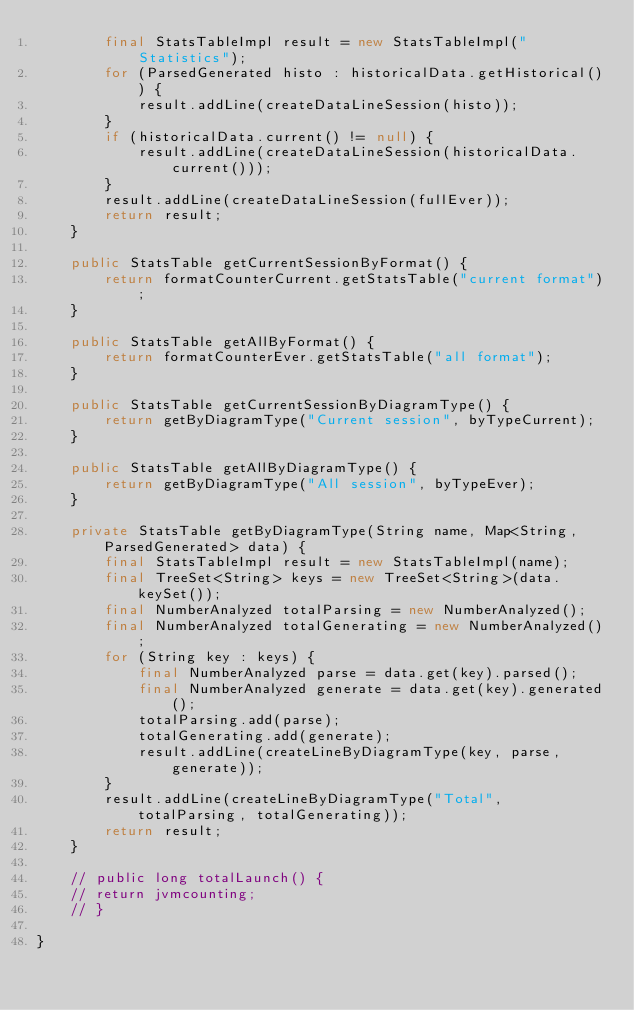<code> <loc_0><loc_0><loc_500><loc_500><_Java_>		final StatsTableImpl result = new StatsTableImpl("Statistics");
		for (ParsedGenerated histo : historicalData.getHistorical()) {
			result.addLine(createDataLineSession(histo));
		}
		if (historicalData.current() != null) {
			result.addLine(createDataLineSession(historicalData.current()));
		}
		result.addLine(createDataLineSession(fullEver));
		return result;
	}

	public StatsTable getCurrentSessionByFormat() {
		return formatCounterCurrent.getStatsTable("current format");
	}

	public StatsTable getAllByFormat() {
		return formatCounterEver.getStatsTable("all format");
	}

	public StatsTable getCurrentSessionByDiagramType() {
		return getByDiagramType("Current session", byTypeCurrent);
	}

	public StatsTable getAllByDiagramType() {
		return getByDiagramType("All session", byTypeEver);
	}

	private StatsTable getByDiagramType(String name, Map<String, ParsedGenerated> data) {
		final StatsTableImpl result = new StatsTableImpl(name);
		final TreeSet<String> keys = new TreeSet<String>(data.keySet());
		final NumberAnalyzed totalParsing = new NumberAnalyzed();
		final NumberAnalyzed totalGenerating = new NumberAnalyzed();
		for (String key : keys) {
			final NumberAnalyzed parse = data.get(key).parsed();
			final NumberAnalyzed generate = data.get(key).generated();
			totalParsing.add(parse);
			totalGenerating.add(generate);
			result.addLine(createLineByDiagramType(key, parse, generate));
		}
		result.addLine(createLineByDiagramType("Total", totalParsing, totalGenerating));
		return result;
	}

	// public long totalLaunch() {
	// return jvmcounting;
	// }

}
</code> 